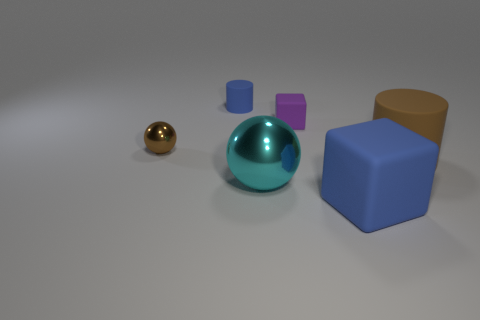Is the number of small blue cylinders on the left side of the small ball the same as the number of red matte cylinders?
Ensure brevity in your answer.  Yes. How many rubber cylinders are on the right side of the block that is to the right of the tiny rubber object in front of the tiny rubber cylinder?
Provide a short and direct response. 1. There is a cylinder in front of the small matte cube; what is its color?
Make the answer very short. Brown. What material is the object that is right of the small purple cube and behind the big matte cube?
Offer a terse response. Rubber. There is a rubber cylinder in front of the brown shiny thing; how many shiny things are in front of it?
Your answer should be very brief. 1. The small brown shiny object is what shape?
Your response must be concise. Sphere. What shape is the small blue thing that is the same material as the big brown cylinder?
Provide a succinct answer. Cylinder. There is a metallic thing that is to the left of the big sphere; is it the same shape as the cyan shiny thing?
Your answer should be compact. Yes. The blue object that is in front of the small shiny ball has what shape?
Keep it short and to the point. Cube. There is a rubber object that is the same color as the big cube; what is its shape?
Provide a short and direct response. Cylinder. 